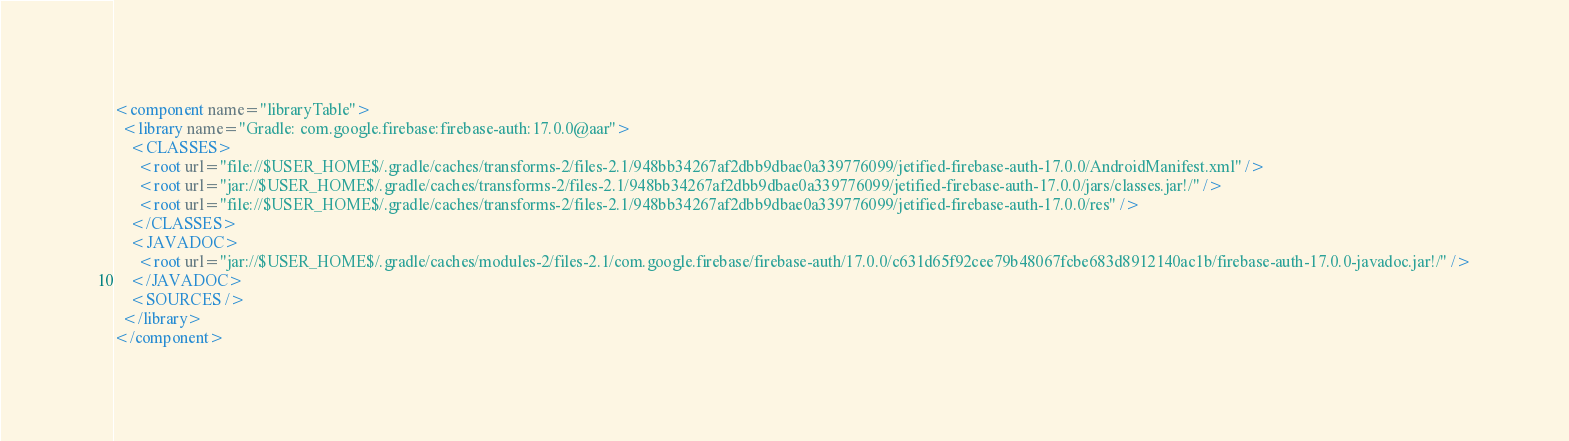<code> <loc_0><loc_0><loc_500><loc_500><_XML_><component name="libraryTable">
  <library name="Gradle: com.google.firebase:firebase-auth:17.0.0@aar">
    <CLASSES>
      <root url="file://$USER_HOME$/.gradle/caches/transforms-2/files-2.1/948bb34267af2dbb9dbae0a339776099/jetified-firebase-auth-17.0.0/AndroidManifest.xml" />
      <root url="jar://$USER_HOME$/.gradle/caches/transforms-2/files-2.1/948bb34267af2dbb9dbae0a339776099/jetified-firebase-auth-17.0.0/jars/classes.jar!/" />
      <root url="file://$USER_HOME$/.gradle/caches/transforms-2/files-2.1/948bb34267af2dbb9dbae0a339776099/jetified-firebase-auth-17.0.0/res" />
    </CLASSES>
    <JAVADOC>
      <root url="jar://$USER_HOME$/.gradle/caches/modules-2/files-2.1/com.google.firebase/firebase-auth/17.0.0/c631d65f92cee79b48067fcbe683d8912140ac1b/firebase-auth-17.0.0-javadoc.jar!/" />
    </JAVADOC>
    <SOURCES />
  </library>
</component></code> 